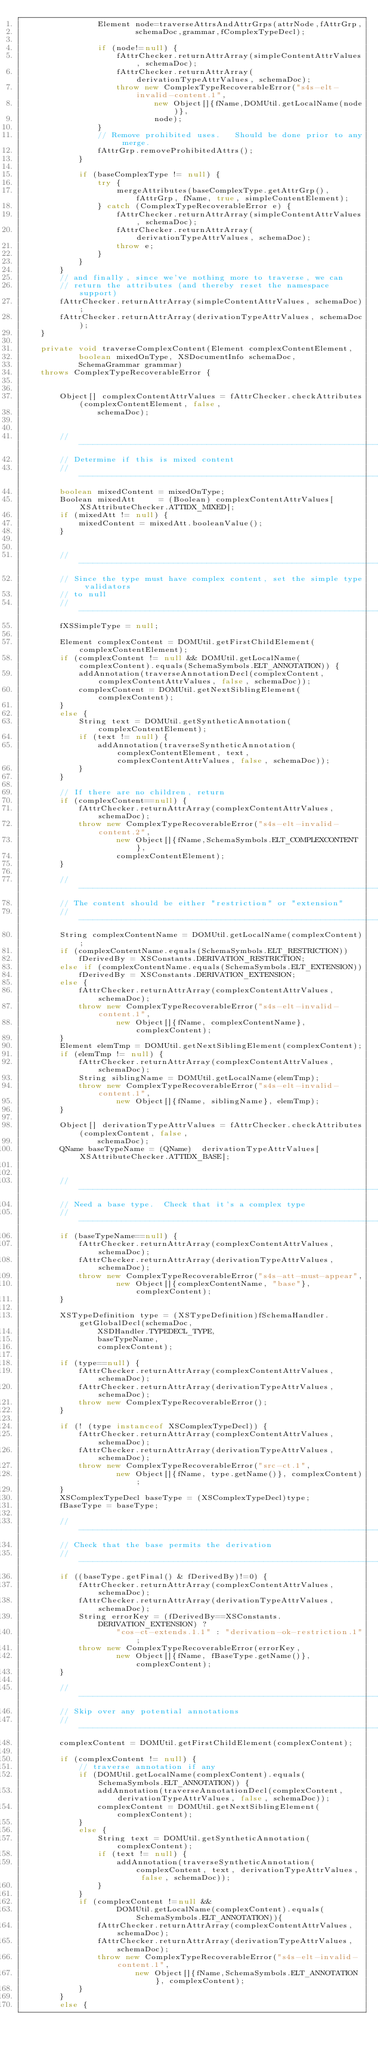Convert code to text. <code><loc_0><loc_0><loc_500><loc_500><_Java_>                Element node=traverseAttrsAndAttrGrps(attrNode,fAttrGrp,
                        schemaDoc,grammar,fComplexTypeDecl);
                
                if (node!=null) {
                    fAttrChecker.returnAttrArray(simpleContentAttrValues, schemaDoc);
                    fAttrChecker.returnAttrArray(derivationTypeAttrValues, schemaDoc);
                    throw new ComplexTypeRecoverableError("s4s-elt-invalid-content.1",
                            new Object[]{fName,DOMUtil.getLocalName(node)},
                            node);
                }
                // Remove prohibited uses.   Should be done prior to any merge.
                fAttrGrp.removeProhibitedAttrs();
            }
            
            if (baseComplexType != null) {
                try {
                    mergeAttributes(baseComplexType.getAttrGrp(), fAttrGrp, fName, true, simpleContentElement);
                } catch (ComplexTypeRecoverableError e) {
                    fAttrChecker.returnAttrArray(simpleContentAttrValues, schemaDoc);
                    fAttrChecker.returnAttrArray(derivationTypeAttrValues, schemaDoc);
                    throw e;
                }
            }
        }
        // and finally, since we've nothing more to traverse, we can
        // return the attributes (and thereby reset the namespace support)
        fAttrChecker.returnAttrArray(simpleContentAttrValues, schemaDoc);
        fAttrChecker.returnAttrArray(derivationTypeAttrValues, schemaDoc);
    }
    
    private void traverseComplexContent(Element complexContentElement,
            boolean mixedOnType, XSDocumentInfo schemaDoc,
            SchemaGrammar grammar)
    throws ComplexTypeRecoverableError {
        
        
        Object[] complexContentAttrValues = fAttrChecker.checkAttributes(complexContentElement, false,
                schemaDoc);
        
        
        // -----------------------------------------------------------------------
        // Determine if this is mixed content
        // -----------------------------------------------------------------------
        boolean mixedContent = mixedOnType;
        Boolean mixedAtt     = (Boolean) complexContentAttrValues[XSAttributeChecker.ATTIDX_MIXED];
        if (mixedAtt != null) {
            mixedContent = mixedAtt.booleanValue();
        }
        
        
        // -----------------------------------------------------------------------
        // Since the type must have complex content, set the simple type validators
        // to null
        // -----------------------------------------------------------------------
        fXSSimpleType = null;
        
        Element complexContent = DOMUtil.getFirstChildElement(complexContentElement);
        if (complexContent != null && DOMUtil.getLocalName(complexContent).equals(SchemaSymbols.ELT_ANNOTATION)) {
            addAnnotation(traverseAnnotationDecl(complexContent, complexContentAttrValues, false, schemaDoc));
            complexContent = DOMUtil.getNextSiblingElement(complexContent);
        }
        else {
            String text = DOMUtil.getSyntheticAnnotation(complexContentElement);
            if (text != null) {
                addAnnotation(traverseSyntheticAnnotation(complexContentElement, text, complexContentAttrValues, false, schemaDoc));
            }
        }
        
        // If there are no children, return
        if (complexContent==null) {
            fAttrChecker.returnAttrArray(complexContentAttrValues, schemaDoc);
            throw new ComplexTypeRecoverableError("s4s-elt-invalid-content.2",
                    new Object[]{fName,SchemaSymbols.ELT_COMPLEXCONTENT},
                    complexContentElement);
        }
        
        // -----------------------------------------------------------------------
        // The content should be either "restriction" or "extension"
        // -----------------------------------------------------------------------
        String complexContentName = DOMUtil.getLocalName(complexContent);
        if (complexContentName.equals(SchemaSymbols.ELT_RESTRICTION))
            fDerivedBy = XSConstants.DERIVATION_RESTRICTION;
        else if (complexContentName.equals(SchemaSymbols.ELT_EXTENSION))
            fDerivedBy = XSConstants.DERIVATION_EXTENSION;
        else {
            fAttrChecker.returnAttrArray(complexContentAttrValues, schemaDoc);
            throw new ComplexTypeRecoverableError("s4s-elt-invalid-content.1",
                    new Object[]{fName, complexContentName}, complexContent);
        }
        Element elemTmp = DOMUtil.getNextSiblingElement(complexContent);
        if (elemTmp != null) {
            fAttrChecker.returnAttrArray(complexContentAttrValues, schemaDoc);
            String siblingName = DOMUtil.getLocalName(elemTmp);
            throw new ComplexTypeRecoverableError("s4s-elt-invalid-content.1",
                    new Object[]{fName, siblingName}, elemTmp);
        }
        
        Object[] derivationTypeAttrValues = fAttrChecker.checkAttributes(complexContent, false,
                schemaDoc);
        QName baseTypeName = (QName)  derivationTypeAttrValues[XSAttributeChecker.ATTIDX_BASE];
        
        
        // -----------------------------------------------------------------------
        // Need a base type.  Check that it's a complex type
        // -----------------------------------------------------------------------
        if (baseTypeName==null) {
            fAttrChecker.returnAttrArray(complexContentAttrValues, schemaDoc);
            fAttrChecker.returnAttrArray(derivationTypeAttrValues, schemaDoc);
            throw new ComplexTypeRecoverableError("s4s-att-must-appear",
                    new Object[]{complexContentName, "base"}, complexContent);
        }
        
        XSTypeDefinition type = (XSTypeDefinition)fSchemaHandler.getGlobalDecl(schemaDoc,
                XSDHandler.TYPEDECL_TYPE,
                baseTypeName,
                complexContent);
        
        if (type==null) {
            fAttrChecker.returnAttrArray(complexContentAttrValues, schemaDoc);
            fAttrChecker.returnAttrArray(derivationTypeAttrValues, schemaDoc);
            throw new ComplexTypeRecoverableError();
        }
        
        if (! (type instanceof XSComplexTypeDecl)) {
            fAttrChecker.returnAttrArray(complexContentAttrValues, schemaDoc);
            fAttrChecker.returnAttrArray(derivationTypeAttrValues, schemaDoc);
            throw new ComplexTypeRecoverableError("src-ct.1",
                    new Object[]{fName, type.getName()}, complexContent);
        }
        XSComplexTypeDecl baseType = (XSComplexTypeDecl)type;
        fBaseType = baseType;
        
        // -----------------------------------------------------------------------
        // Check that the base permits the derivation
        // -----------------------------------------------------------------------
        if ((baseType.getFinal() & fDerivedBy)!=0) {
            fAttrChecker.returnAttrArray(complexContentAttrValues, schemaDoc);
            fAttrChecker.returnAttrArray(derivationTypeAttrValues, schemaDoc);
            String errorKey = (fDerivedBy==XSConstants.DERIVATION_EXTENSION) ?
                    "cos-ct-extends.1.1" : "derivation-ok-restriction.1";
            throw new ComplexTypeRecoverableError(errorKey,
                    new Object[]{fName, fBaseType.getName()}, complexContent);
        }
        
        // -----------------------------------------------------------------------
        // Skip over any potential annotations
        // -----------------------------------------------------------------------
        complexContent = DOMUtil.getFirstChildElement(complexContent);
        
        if (complexContent != null) {
            // traverse annotation if any
            if (DOMUtil.getLocalName(complexContent).equals(SchemaSymbols.ELT_ANNOTATION)) {
                addAnnotation(traverseAnnotationDecl(complexContent, derivationTypeAttrValues, false, schemaDoc));
                complexContent = DOMUtil.getNextSiblingElement(complexContent);
            }
            else {
                String text = DOMUtil.getSyntheticAnnotation(complexContent);
                if (text != null) {
                    addAnnotation(traverseSyntheticAnnotation(complexContent, text, derivationTypeAttrValues, false, schemaDoc));
                }
            }
            if (complexContent !=null &&
                    DOMUtil.getLocalName(complexContent).equals(SchemaSymbols.ELT_ANNOTATION)){
                fAttrChecker.returnAttrArray(complexContentAttrValues, schemaDoc);
                fAttrChecker.returnAttrArray(derivationTypeAttrValues, schemaDoc);
                throw new ComplexTypeRecoverableError("s4s-elt-invalid-content.1",
                        new Object[]{fName,SchemaSymbols.ELT_ANNOTATION}, complexContent);
            }
        }
        else {</code> 